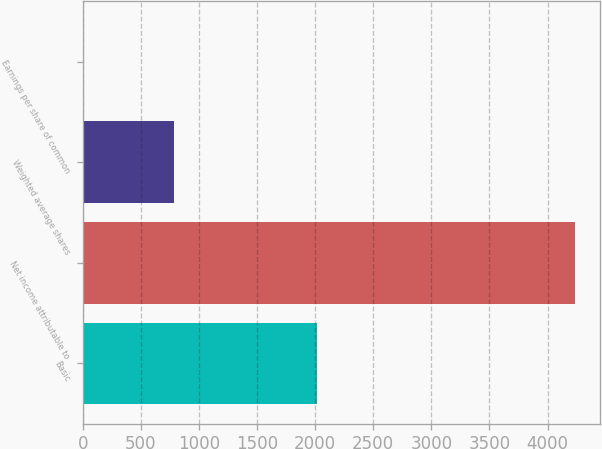Convert chart to OTSL. <chart><loc_0><loc_0><loc_500><loc_500><bar_chart><fcel>Basic<fcel>Net income attributable to<fcel>Weighted average shares<fcel>Earnings per share of common<nl><fcel>2014<fcel>4239<fcel>784.4<fcel>5.4<nl></chart> 